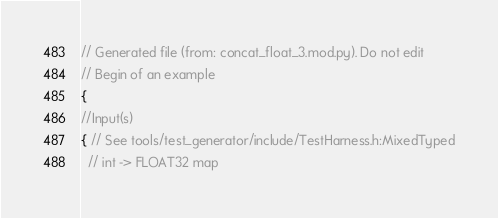<code> <loc_0><loc_0><loc_500><loc_500><_C++_>// Generated file (from: concat_float_3.mod.py). Do not edit
// Begin of an example
{
//Input(s)
{ // See tools/test_generator/include/TestHarness.h:MixedTyped
  // int -> FLOAT32 map</code> 